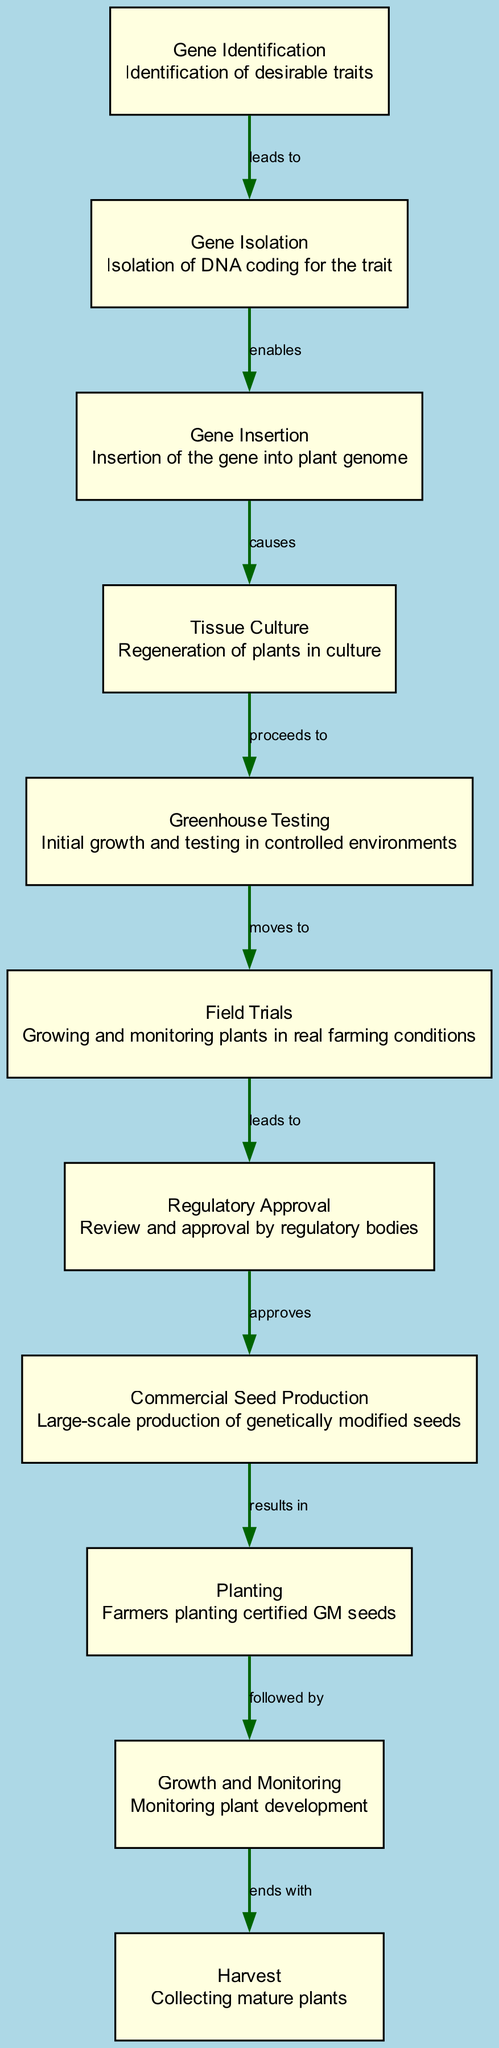What is the first step in the lifecycle of genetically modified crops? The diagram indicates that the first step is "Gene Identification," which involves identifying desirable traits.
Answer: Gene Identification Which step involves the regeneration of plants in culture? According to the diagram, the step related to plant regeneration in culture is "Tissue Culture."
Answer: Tissue Culture How many total nodes are in the diagram? By counting the provided nodes in the diagram, it's clear there are a total of 11 nodes.
Answer: 11 What follows after Greenhouse Testing in the lifecycle? The diagram shows that after "Greenhouse Testing," the process "moves to" the next step, which is "Field Trials."
Answer: Field Trials Which step leads to regulatory approval? The diagram indicates that "Field Trials" is the step that "leads to" "Regulatory Approval."
Answer: Field Trials What is the last phase in the lifecycle of genetically modified crops? The final phase in the diagram is marked as "Harvest," where mature plants are collected.
Answer: Harvest What action does "Regulatory Approval" approve? The diagram specifies that "Regulatory Approval" "approves" the next step, which is "Commercial Seed Production."
Answer: Commercial Seed Production What step comes after Farmers planting certified GM seeds? As described in the diagram, after the step of "Planting," the next action is "Growth and Monitoring."
Answer: Growth and Monitoring Which step causes the insertion of the gene into the plant genome? According to the diagram, "Gene Insertion" is the step that "causes" this action.
Answer: Gene Insertion 